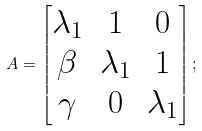<formula> <loc_0><loc_0><loc_500><loc_500>A = \begin{bmatrix} \lambda _ { 1 } & 1 & 0 \\ \beta & \lambda _ { 1 } & 1 \\ \gamma & 0 & \lambda _ { 1 } \end{bmatrix} ;</formula> 